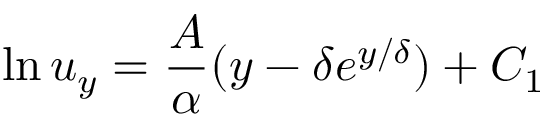<formula> <loc_0><loc_0><loc_500><loc_500>\ln u _ { y } = \frac { A } { \alpha } ( y - \delta e ^ { { y } / { \delta } } ) + C _ { 1 }</formula> 